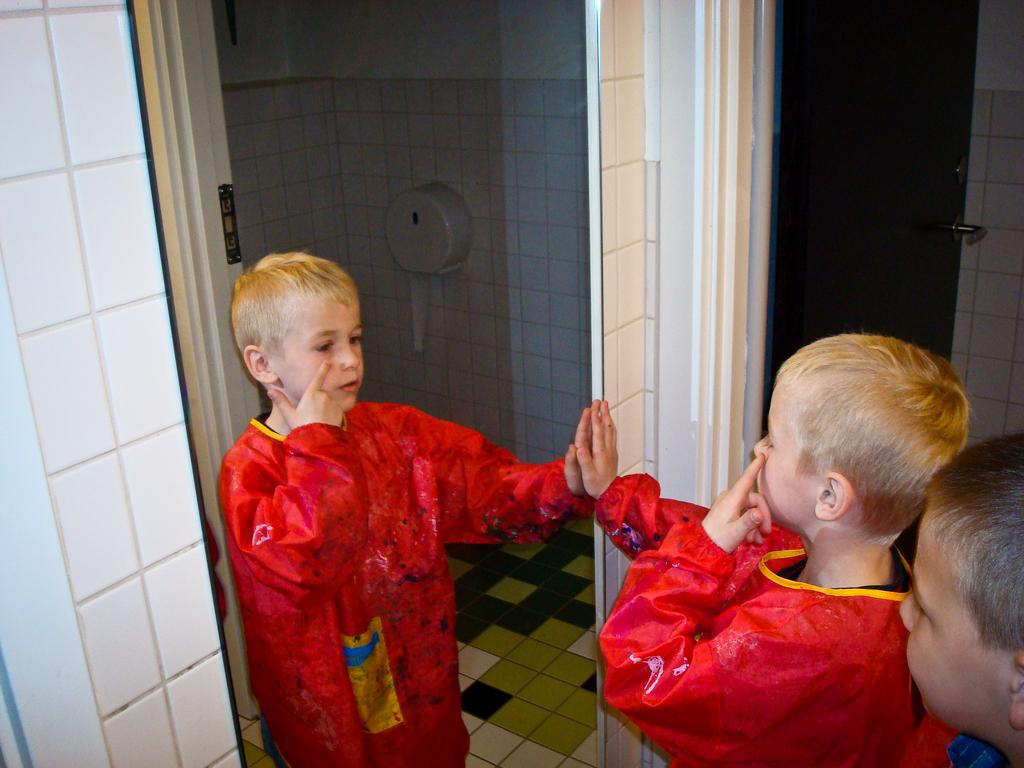How many children are in the image? There are two children in the image. What are the children doing in the image? The children are standing in front of a mirror. What object related to hygiene can be seen in the image? There is a tissue roll in the image. What architectural feature is present in the image? There is a door in the image. What type of surface is visible in the image? The floor is visible in the image. What is the background of the image made of? The background of the image is a wall. What type of coat is the donkey wearing in the image? There is no donkey present in the image, and therefore no coat can be observed. 